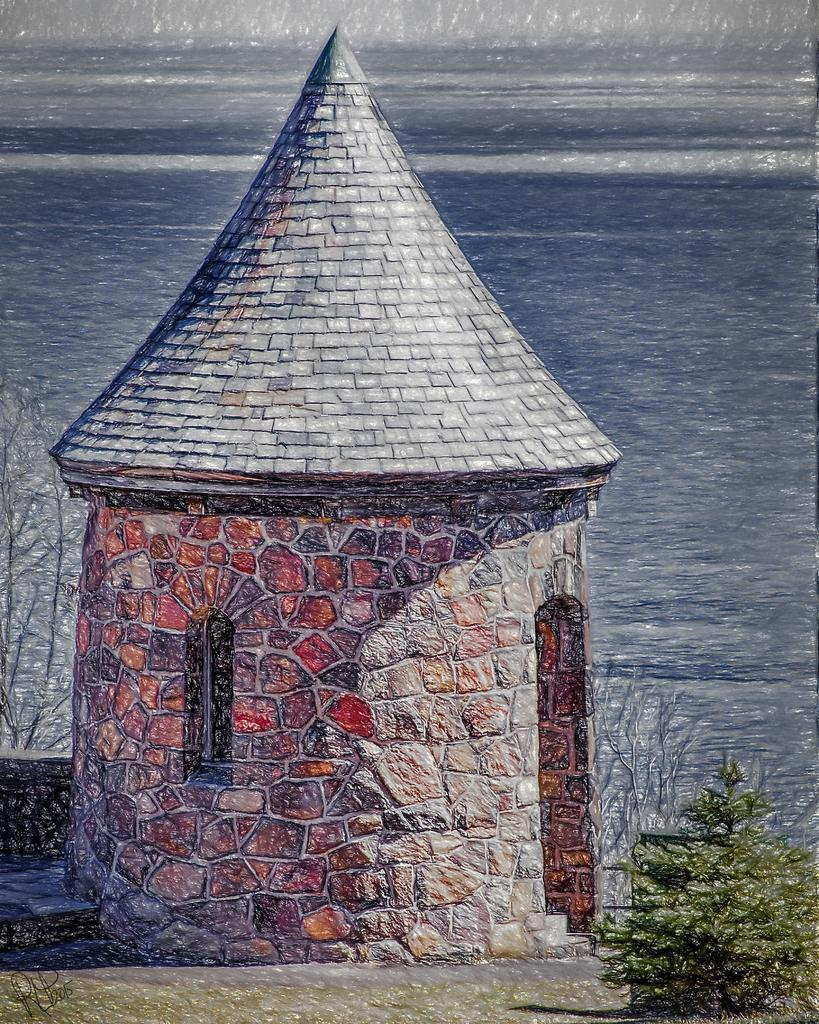What is depicted in the image? There is a drawing of a house in the image. What features can be seen on the house? The house has a roof, stairs, and a door. Are there any plants visible in the image? Yes, there are plants visible in the image. What else can be seen in the background of the image? There is a large water body in the image. Where is the scarecrow placed in the image? There is no scarecrow present in the image. How low is the pocket on the house in the image? There is no pocket mentioned or depicted in the image. 